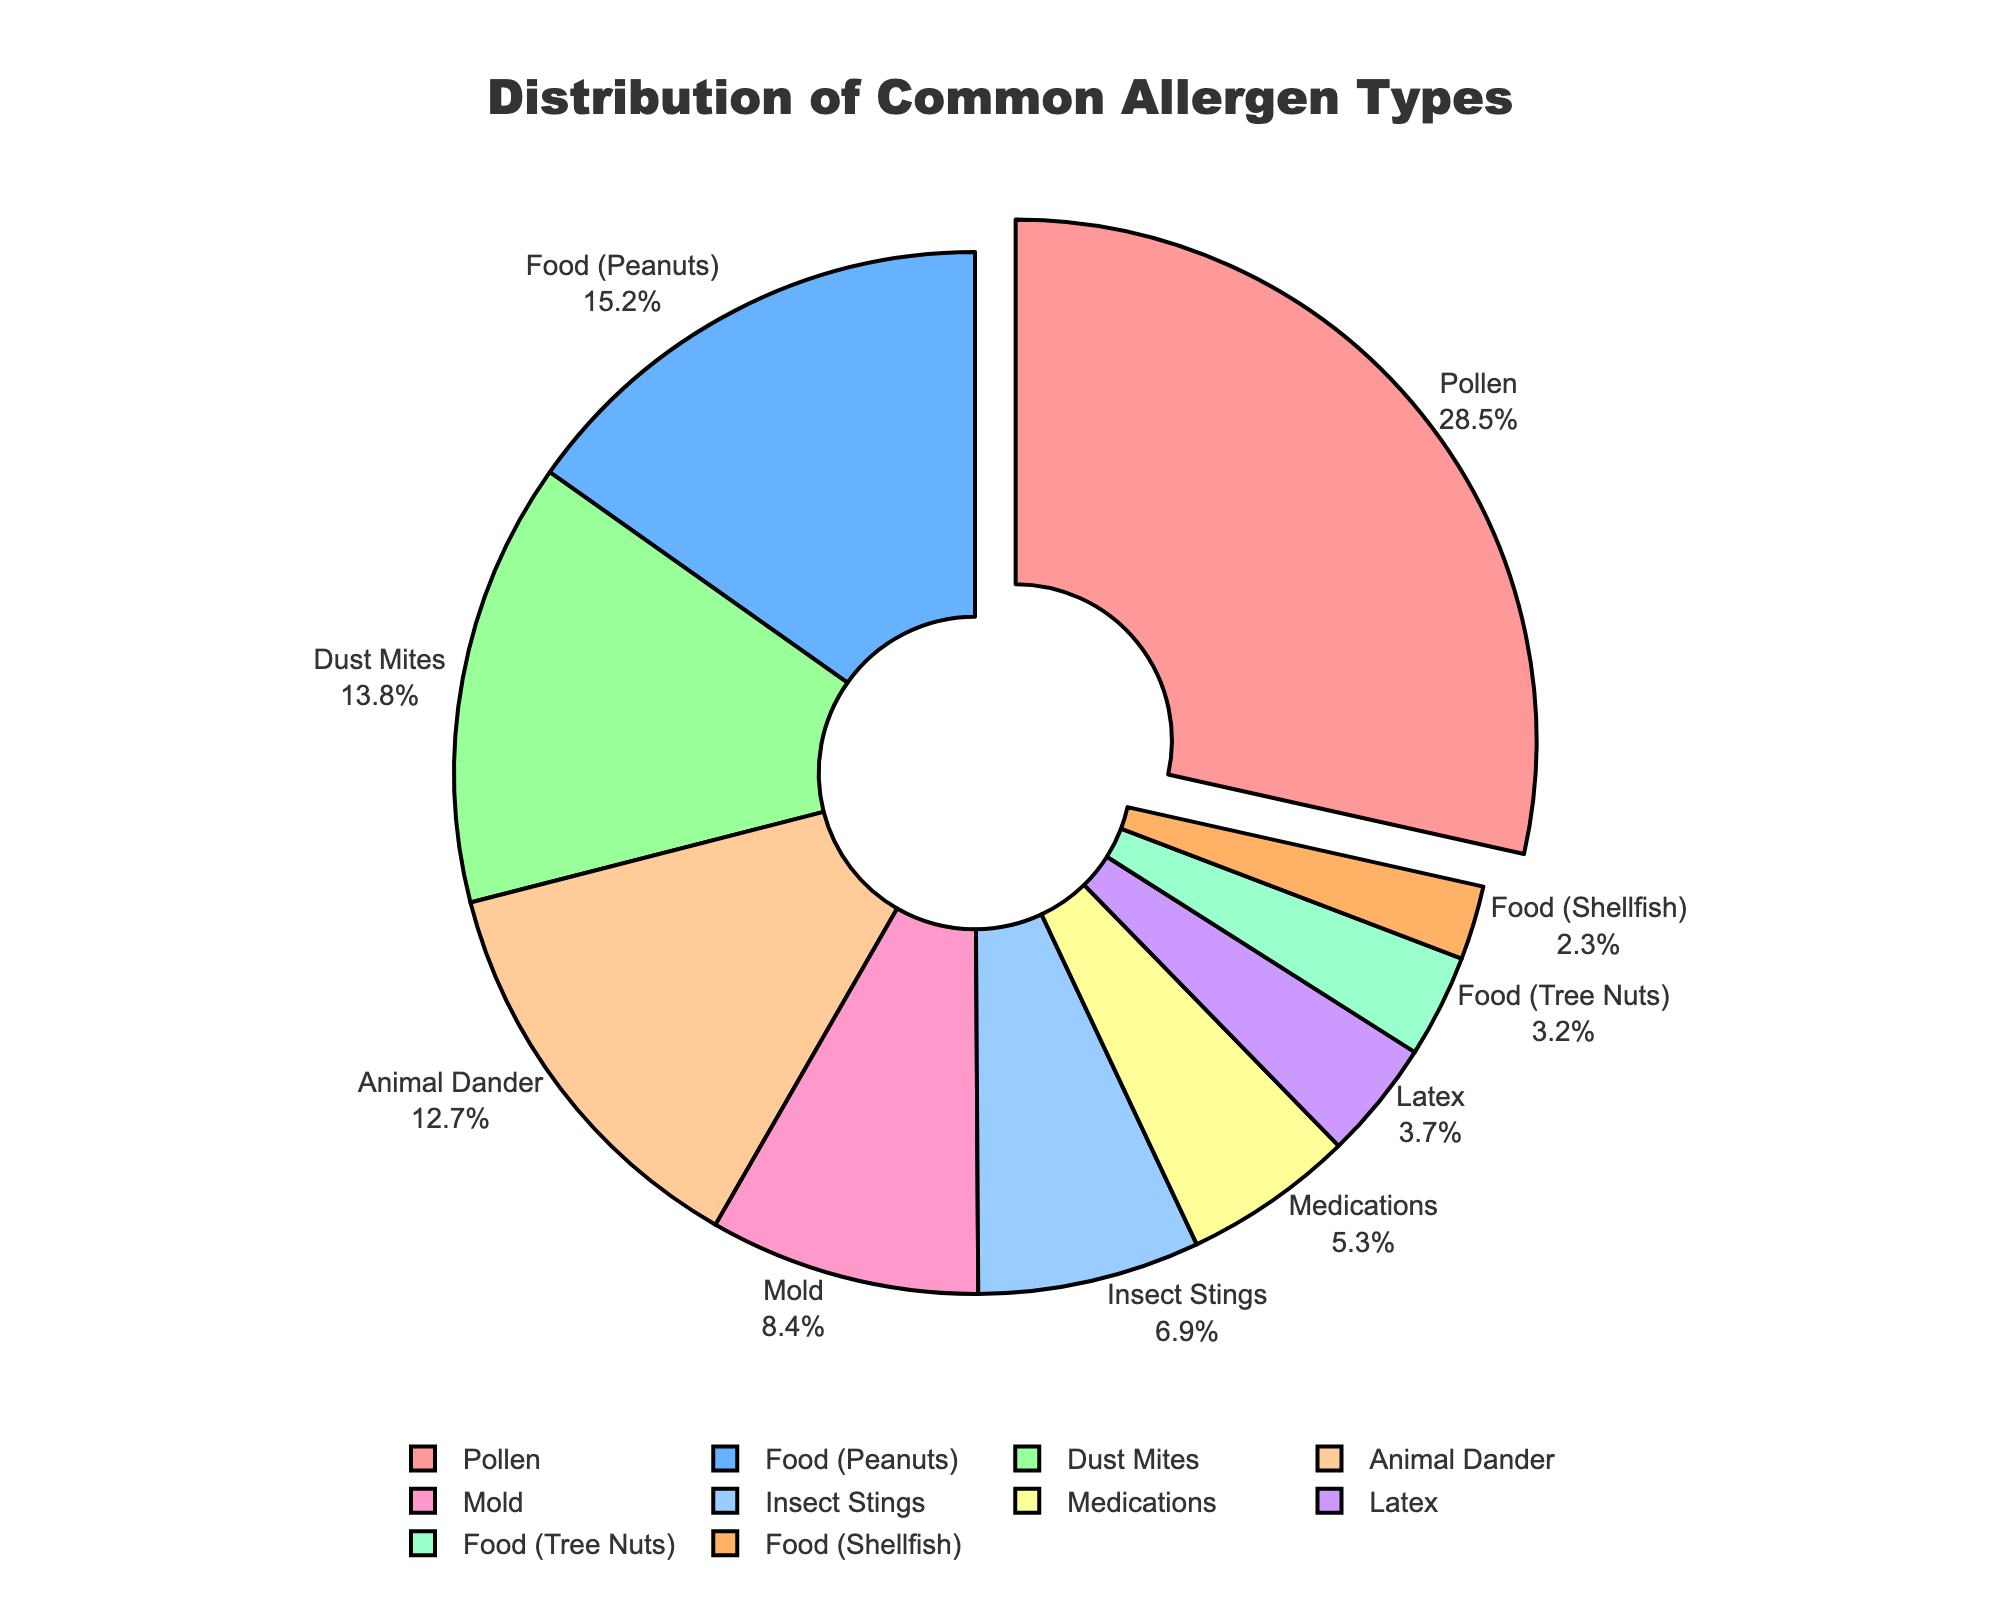What's the most common allergen type reported? The most substantial segment of the pie chart is noted for Pollen, occupying a notable 28.5%.
Answer: Pollen Which allergen type is the least common in the reported cases? By examining the pie chart, Food (Shellfish) is the smallest segment, making up only 2.3% of the cases.
Answer: Food (Shellfish) What is the combined percentage of all food-related allergens? To determine the total proportion for food-related allergens, we add up the percentages for Food (Peanuts), Food (Tree Nuts), and Food (Shellfish): 15.2% + 3.2% + 2.3% = 20.7%.
Answer: 20.7% How much larger is the percentage of Pollen allergies compared to Dust Mites? To find the difference, subtract the percentage of Dust Mites from that of Pollen: 28.5% - 13.8% = 14.7%.
Answer: 14.7% Which allergens occupy less than 5% of the total reported cases? Reviewing the chart, Medications (5.3%), Latex (3.7%), Food (Tree Nuts) (3.2%), and Food (Shellfish) (2.3%) all have less than 5%.
Answer: Latex, Food (Tree Nuts), Food (Shellfish) By what factor is Pollen more common than Mold? The proportion of Pollen (28.5%) divided by that of Mold (8.4%) results in 28.5 / 8.4 ≈ 3.39, indicating that Pollen is approximately 3.39 times more common than Mold.
Answer: 3.39 What percentage of reported allergy cases are related to household allergens (Dust Mites, Mold, Animal Dander)? To calculate this, sum the percentages of Dust Mites, Mold, and Animal Dander: 13.8% + 8.4% + 12.7% = 34.9%.
Answer: 34.9% Considering the pie chart’s visual design, what feature stands out for Pollen? The slice representing Pollen is pulled out from the rest of the pie chart, drawing special attention to it.
Answer: Pull-out Which allergen categories are nearly equal in their reported percentages? Dust Mites (13.8%) and Animal Dander (12.7%) have almost similar proportions, with only a 1.1% difference between them.
Answer: Dust Mites and Animal Dander What's the total percentage of non-food allergens in the report? Subtract the combined percentage of all food-related allergens from 100%: 100% - 20.7% = 79.3%.
Answer: 79.3% 